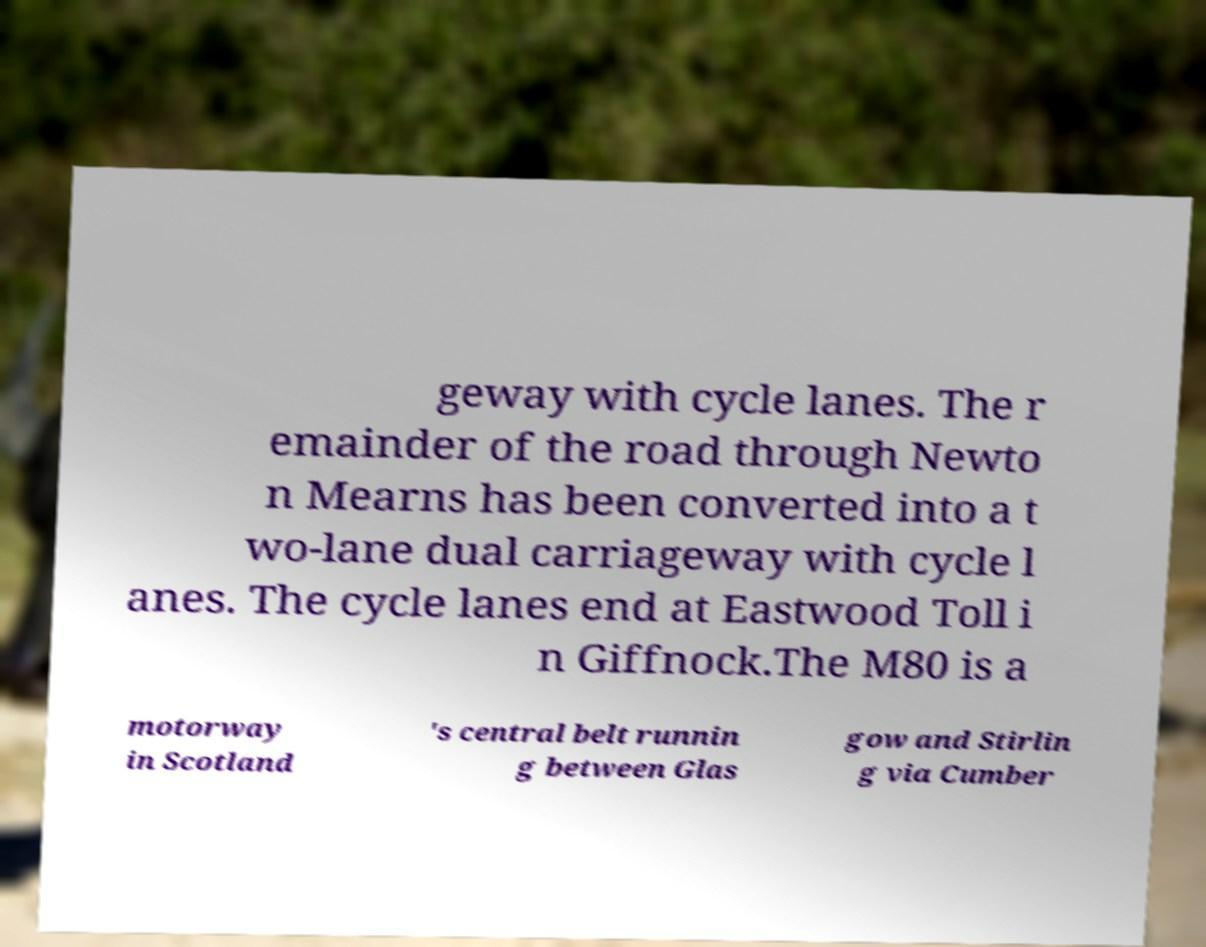Could you extract and type out the text from this image? geway with cycle lanes. The r emainder of the road through Newto n Mearns has been converted into a t wo-lane dual carriageway with cycle l anes. The cycle lanes end at Eastwood Toll i n Giffnock.The M80 is a motorway in Scotland 's central belt runnin g between Glas gow and Stirlin g via Cumber 